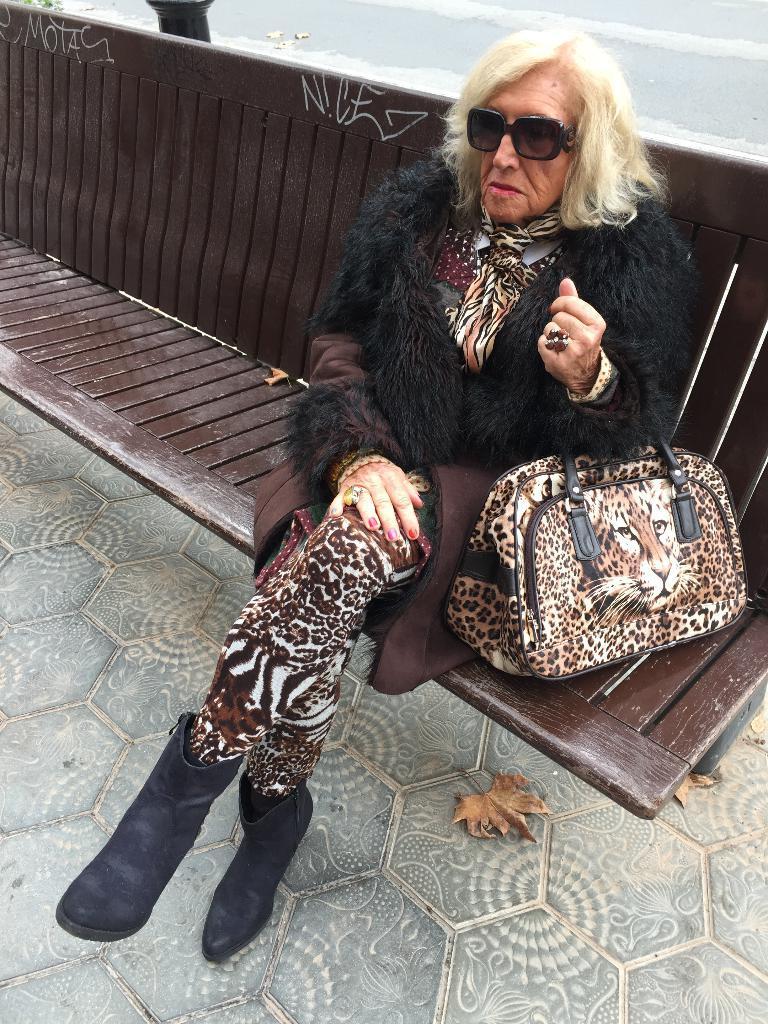Please provide a concise description of this image. In this picture we can see an old woman sitting on bench and she is having handbag. On her handbag, tiger face is visible. She is wearing shoes and spectacles. 